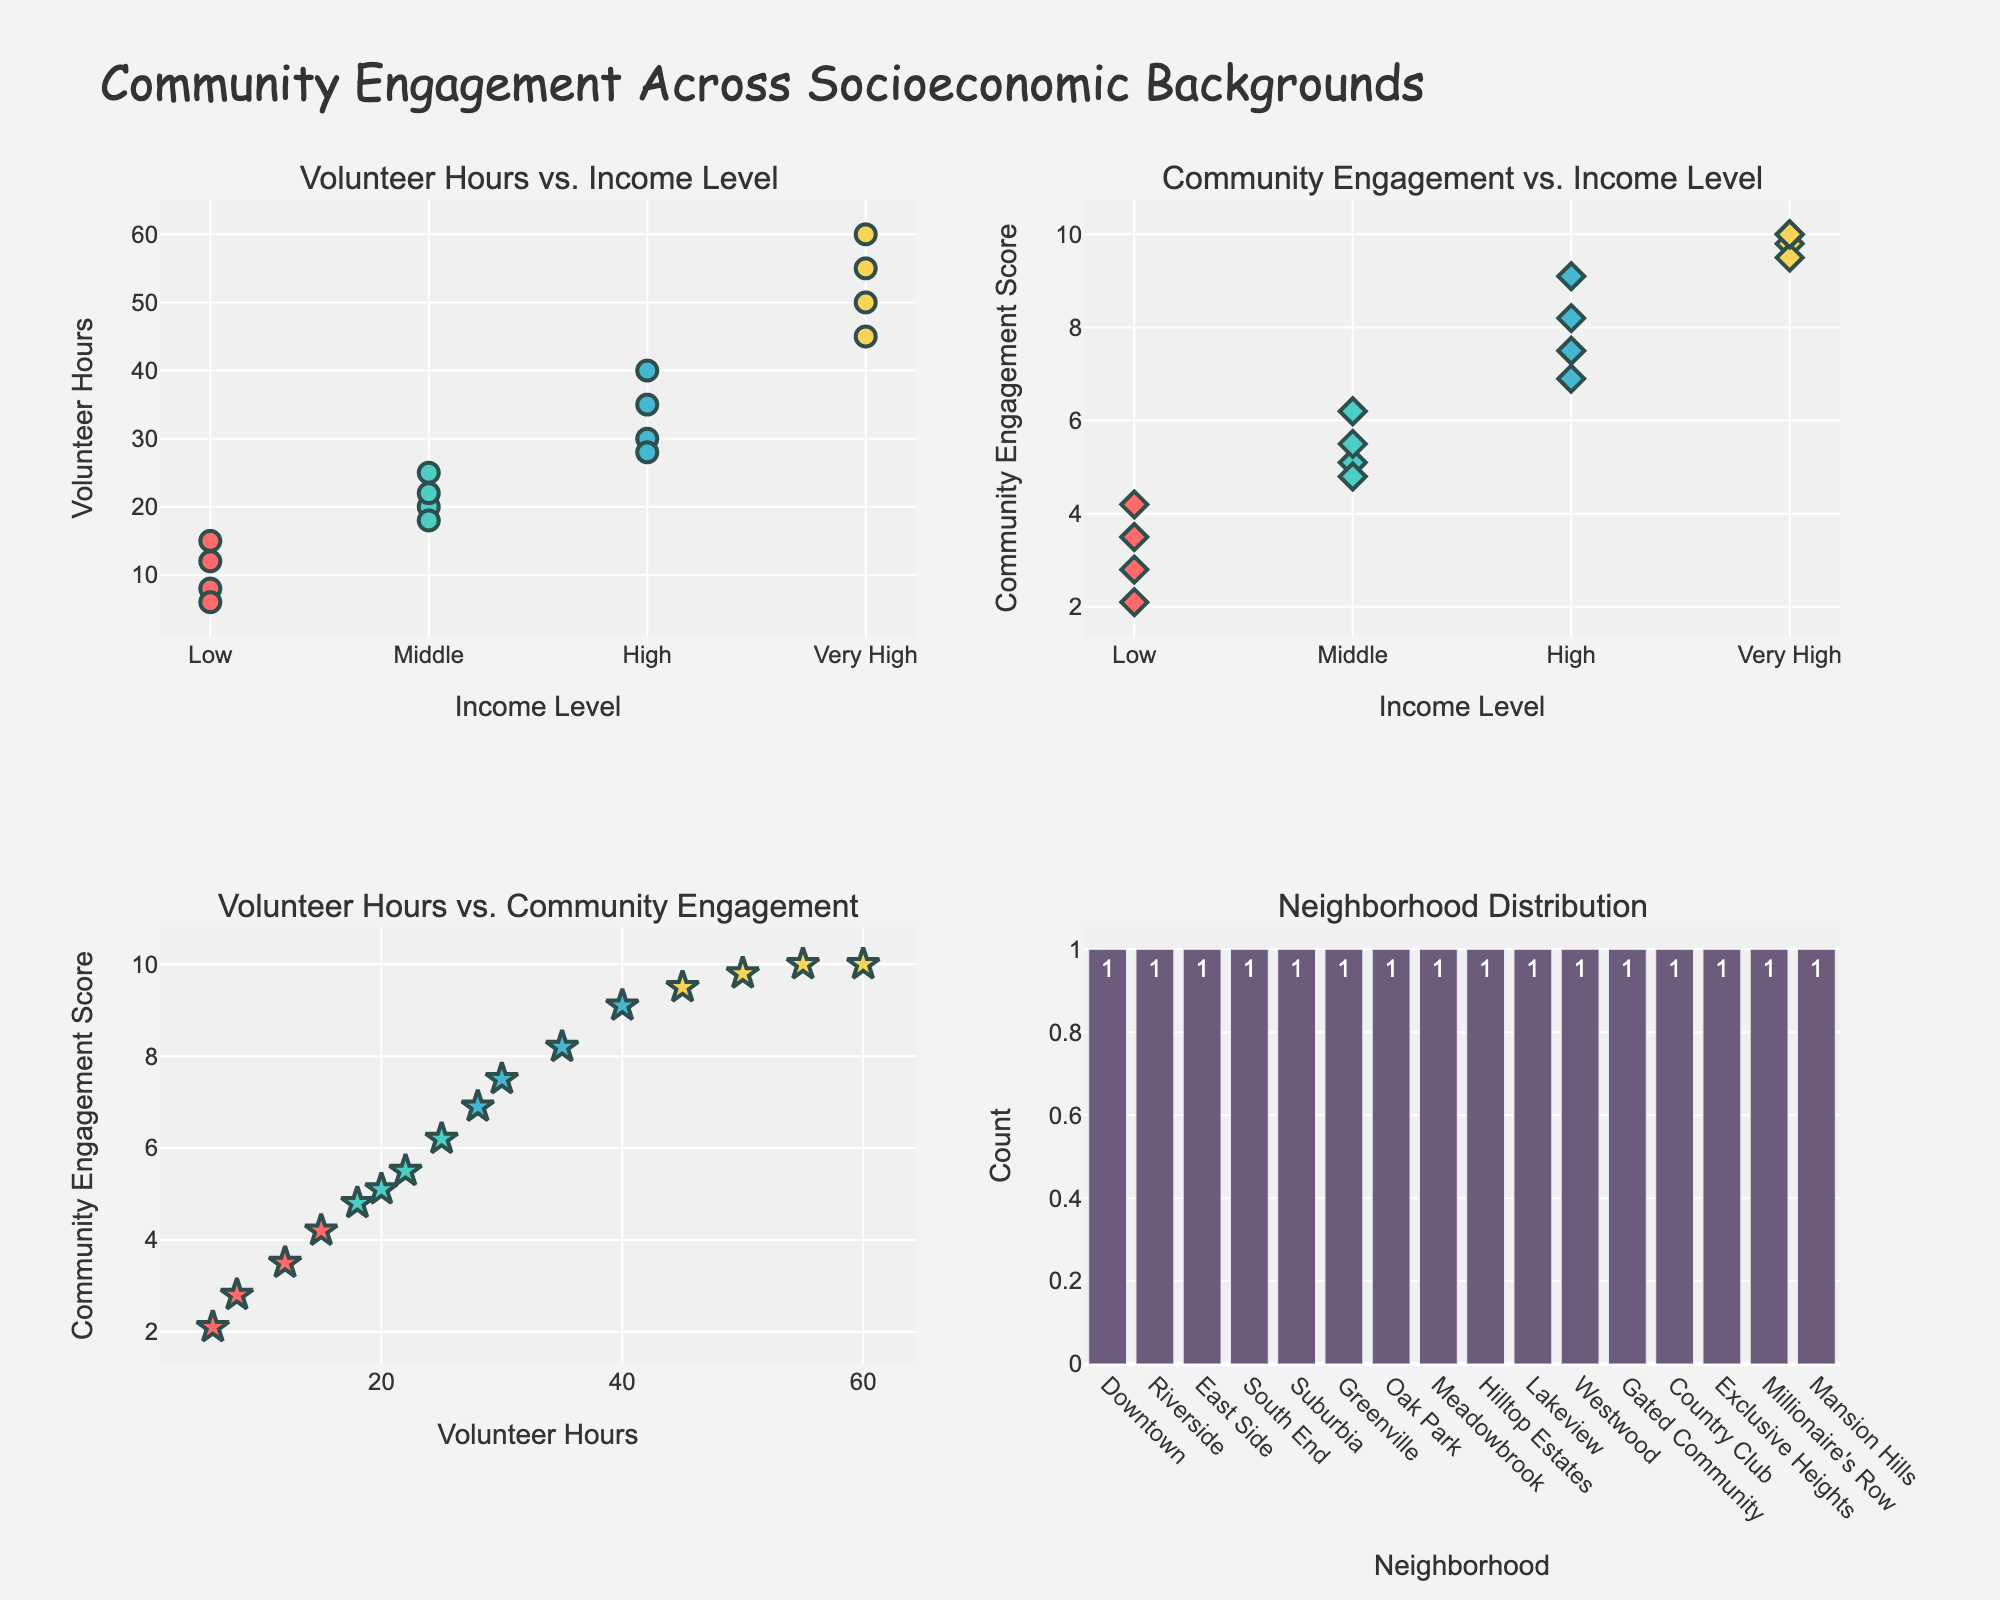What's the title of the figure? The title is placed at the top of the figure and gives an overview of what the plot represents.
Answer: Community Engagement Across Socioeconomic Backgrounds What does the x-axis represent in the first subplot (top left)? The x-axis in the first subplot represents the income level of different groups. This is indicated by the label and category ticks on the x-axis.
Answer: Income Level Which income level has the highest average volunteer hours? Observing the first subplot showing Volunteer Hours vs. Income Level, the 'Very High' income level has the data points with the highest counts.
Answer: Very High What is the color used to represent the "Low" income level? In the scatter plots, each income level has a unique color. The "Low" income level is represented using a color close to red.
Answer: Red Which neighborhood had the maximum volunteer hours? By hovering over the data points on the first subplot, the neighborhood with 60 volunteer hours can be identified as Mansion Hills from the hover text.
Answer: Mansion Hills How many neighborhoods are represented in the bar plot (bottom right)? Counting the bars on the Neighborhood Distribution plot indicates the number of unique neighborhoods.
Answer: 16 Is there a positive correlation between volunteer hours and community engagement scores? Observing the third subplot (Volunteer Hours vs. Community Engagement), the trend shows that data points generally move upwards as volunteer hours increase, indicating a positive correlation.
Answer: Yes Which income level has the highest community engagement score and what is the value? In the second subplot (Community Engagement vs. Income Level), the highest score is 10, visible under the 'Very High' income level category.
Answer: Very High, 10 How does the community engagement score differ between "Low" and "High" income levels? Comparing the points in the second subplot, "Low" income levels have community engagement scores ranging between 2.1 and 4.2, while "High" income levels range from 6.9 to 9.1, showing higher scores for the "High" income level.
Answer: Higher in "High" income level What is the range of volunteer hours for the "Middle" income level? By examining the data points in the first subplot, volunteer hours for "Middle" range from 18 to 25 hours.
Answer: 18 to 25 hours 